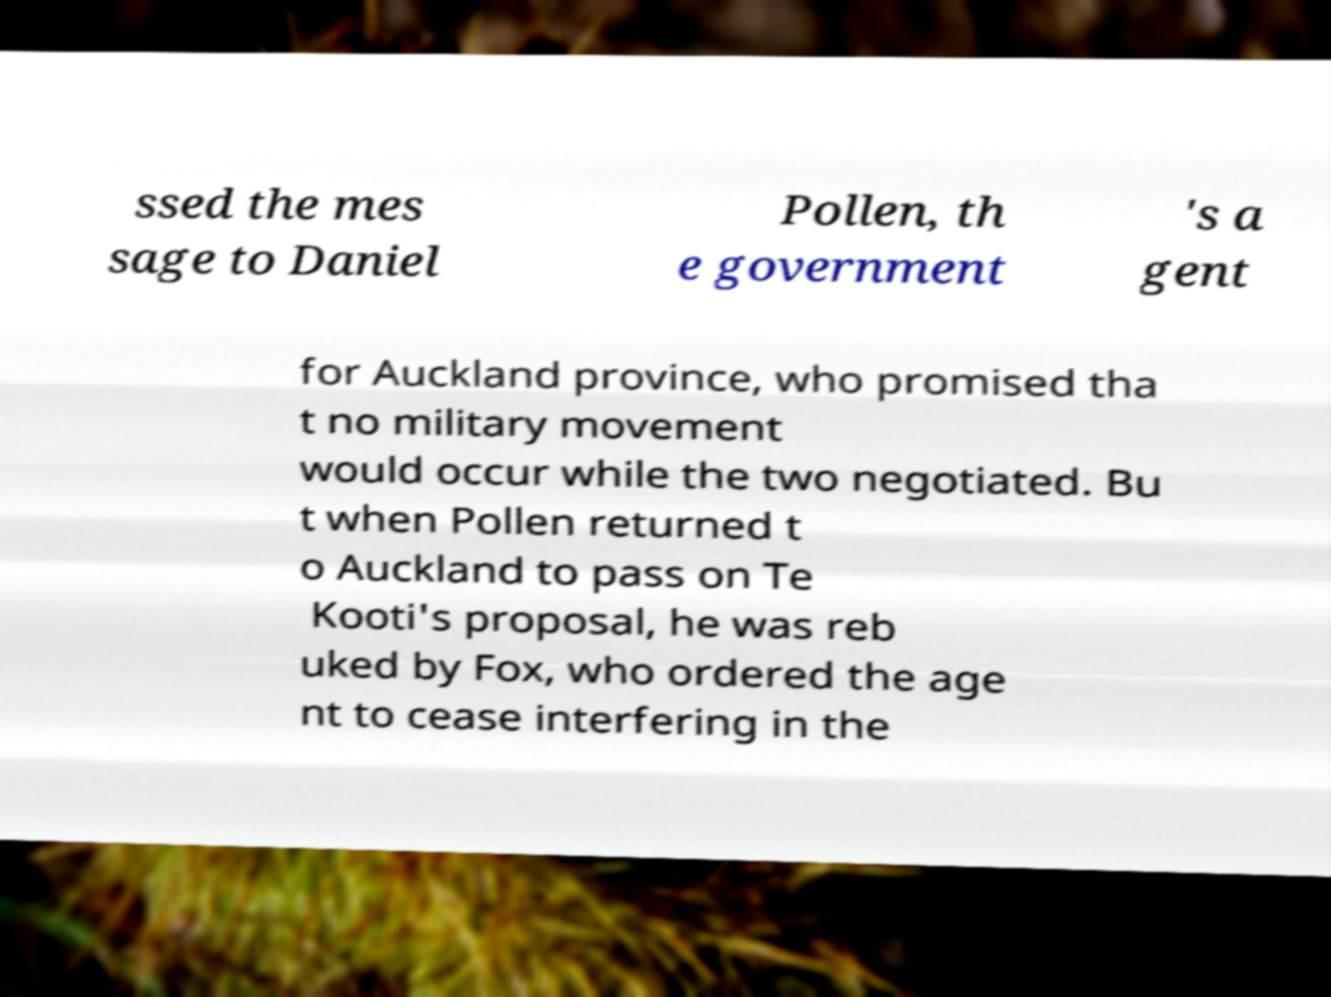Please identify and transcribe the text found in this image. ssed the mes sage to Daniel Pollen, th e government 's a gent for Auckland province, who promised tha t no military movement would occur while the two negotiated. Bu t when Pollen returned t o Auckland to pass on Te Kooti's proposal, he was reb uked by Fox, who ordered the age nt to cease interfering in the 